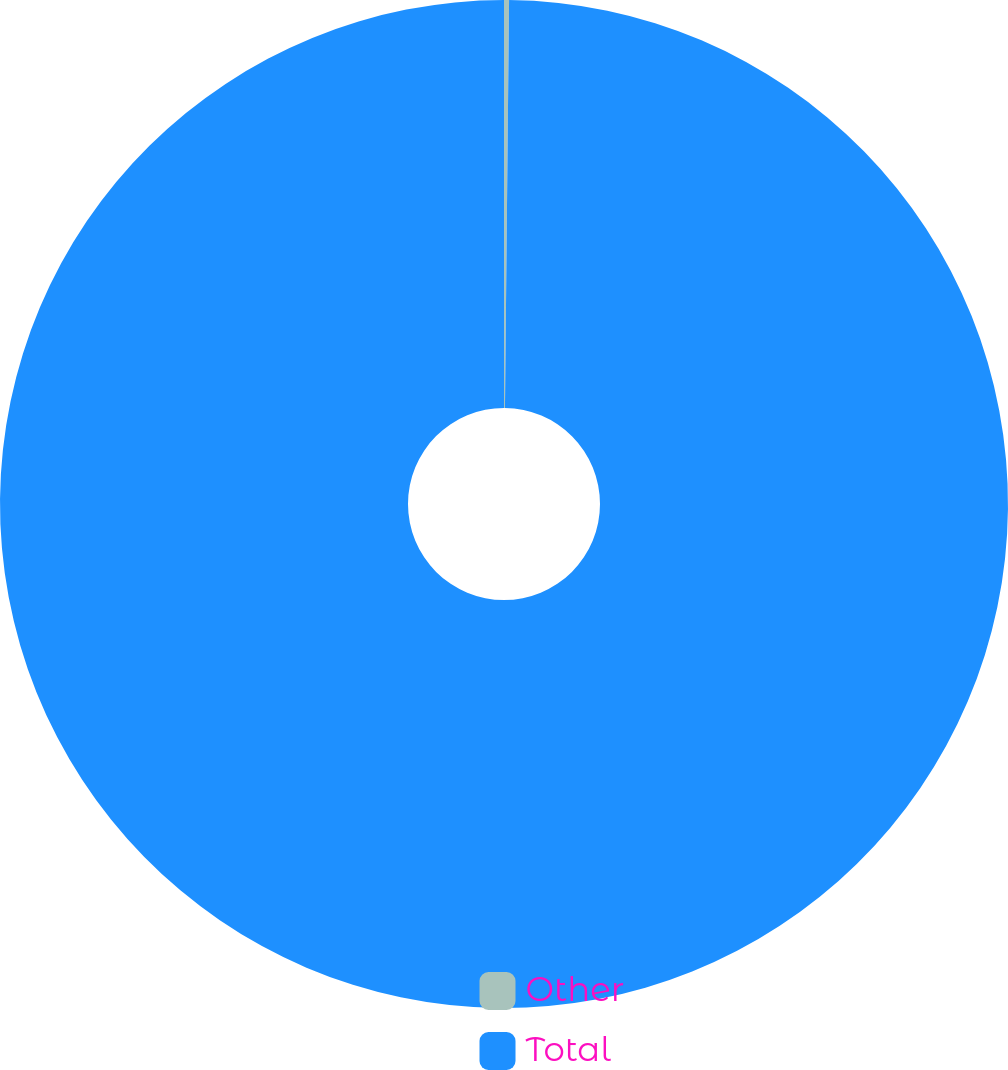<chart> <loc_0><loc_0><loc_500><loc_500><pie_chart><fcel>Other<fcel>Total<nl><fcel>0.16%<fcel>99.84%<nl></chart> 